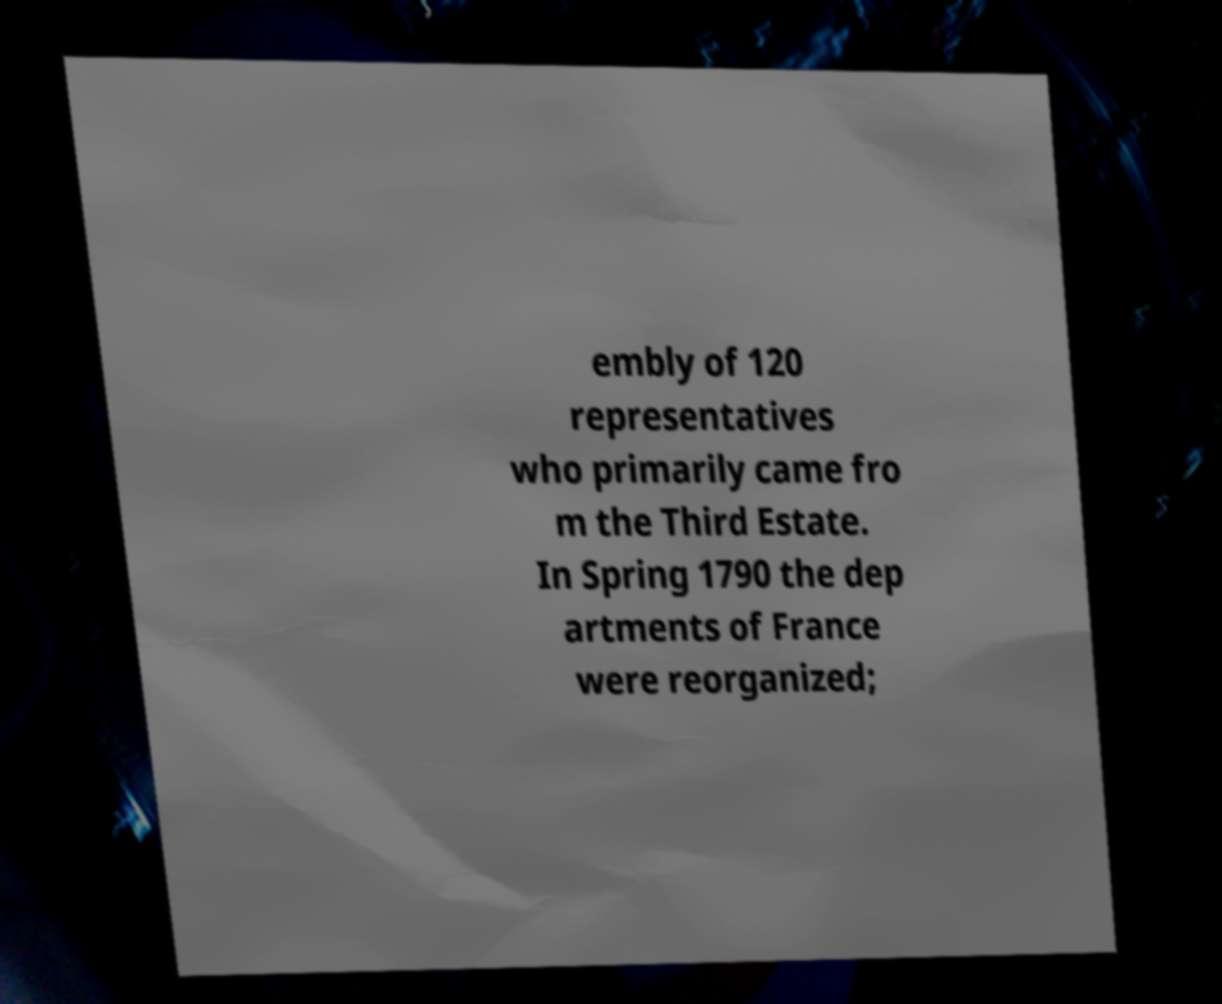Can you read and provide the text displayed in the image?This photo seems to have some interesting text. Can you extract and type it out for me? embly of 120 representatives who primarily came fro m the Third Estate. In Spring 1790 the dep artments of France were reorganized; 